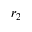Convert formula to latex. <formula><loc_0><loc_0><loc_500><loc_500>r _ { 2 }</formula> 